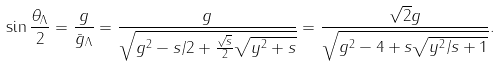Convert formula to latex. <formula><loc_0><loc_0><loc_500><loc_500>\sin \frac { \theta _ { \Lambda } } { 2 } = \frac { g } { \bar { g } _ { \Lambda } } = \frac { g } { \sqrt { g ^ { 2 } - s / 2 + \frac { \sqrt { s } } { 2 } \sqrt { y ^ { 2 } + s } } } = \frac { \sqrt { 2 } g } { \sqrt { g ^ { 2 } - 4 + s \sqrt { y ^ { 2 } / s + 1 } } } .</formula> 